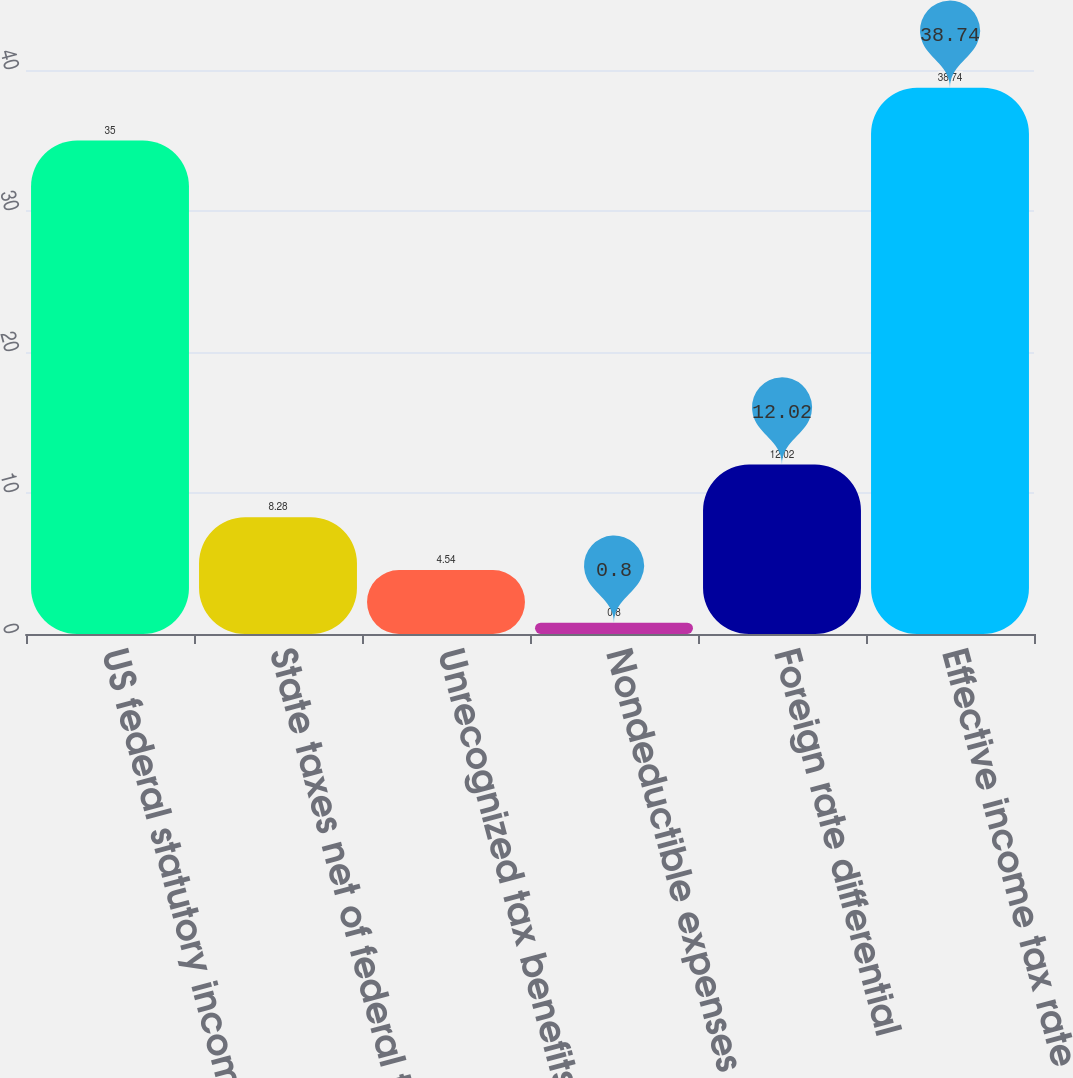Convert chart to OTSL. <chart><loc_0><loc_0><loc_500><loc_500><bar_chart><fcel>US federal statutory income<fcel>State taxes net of federal tax<fcel>Unrecognized tax benefits<fcel>Nondeductible expenses<fcel>Foreign rate differential<fcel>Effective income tax rate<nl><fcel>35<fcel>8.28<fcel>4.54<fcel>0.8<fcel>12.02<fcel>38.74<nl></chart> 